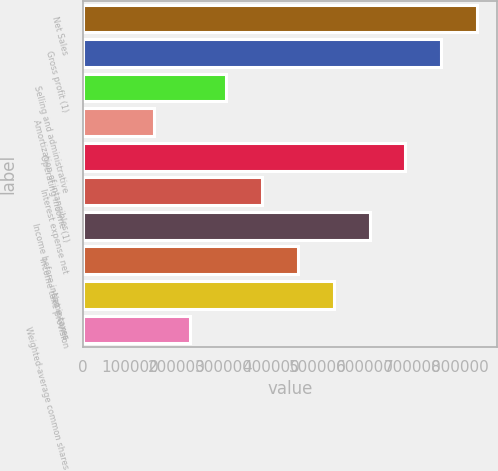Convert chart to OTSL. <chart><loc_0><loc_0><loc_500><loc_500><bar_chart><fcel>Net Sales<fcel>Gross profit (1)<fcel>Selling and administrative<fcel>Amortization of intangibles<fcel>Operating income (1)<fcel>Interest expense net<fcel>Income before income taxes<fcel>Income taxe provision<fcel>Net income<fcel>Weighted-average common shares<nl><fcel>837707<fcel>761552<fcel>304623<fcel>152313<fcel>685397<fcel>380778<fcel>609242<fcel>456933<fcel>533087<fcel>228468<nl></chart> 